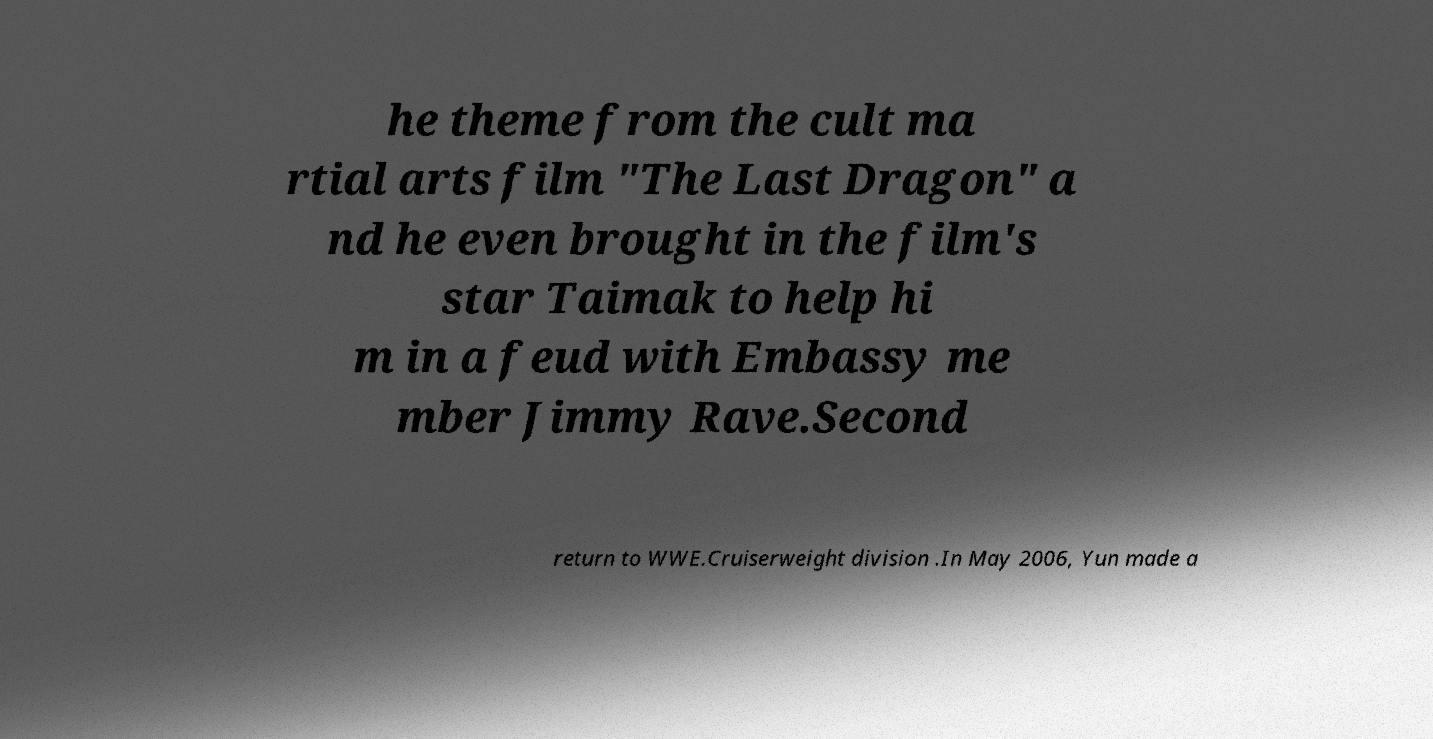There's text embedded in this image that I need extracted. Can you transcribe it verbatim? he theme from the cult ma rtial arts film "The Last Dragon" a nd he even brought in the film's star Taimak to help hi m in a feud with Embassy me mber Jimmy Rave.Second return to WWE.Cruiserweight division .In May 2006, Yun made a 